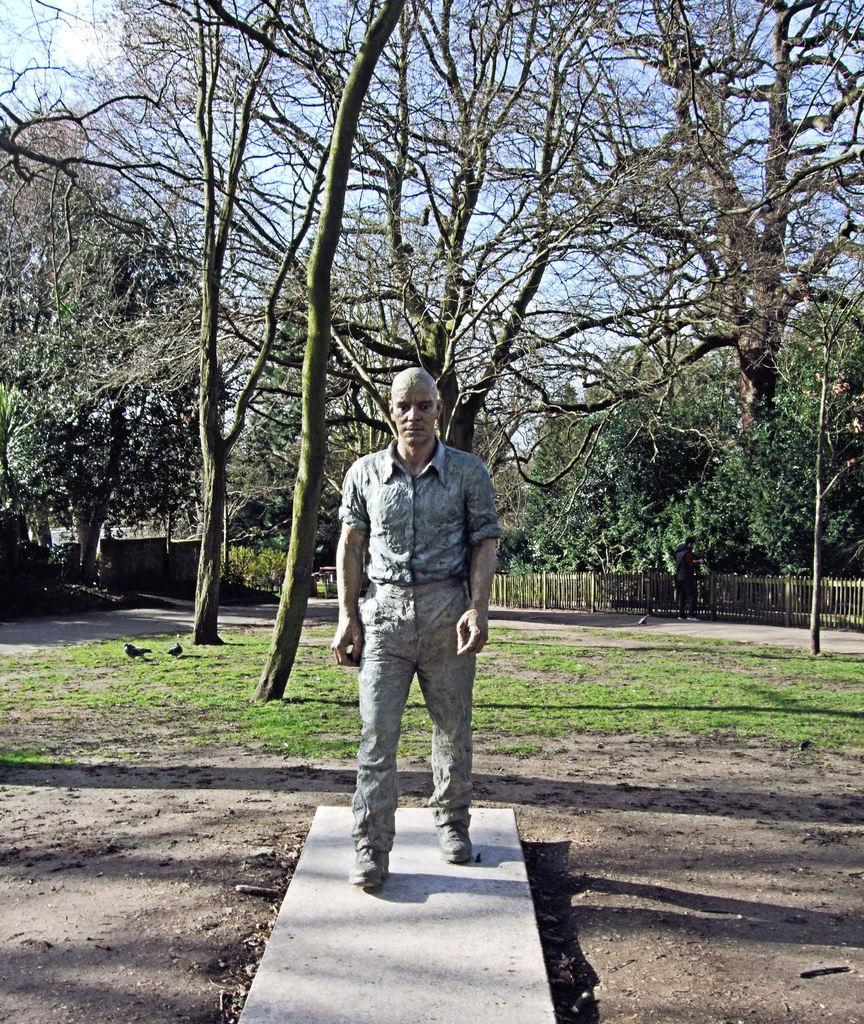Could you give a brief overview of what you see in this image? In the picture we can see the sculpture of a man on the surface and behind it, we can see the surface with grass and trees and from the trees we can see a part of the sky. 